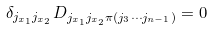Convert formula to latex. <formula><loc_0><loc_0><loc_500><loc_500>\delta _ { j _ { x _ { 1 } } j _ { x _ { 2 } } } D _ { j _ { x _ { 1 } } j _ { x _ { 2 } } \pi ( j _ { 3 } \cdots j _ { n - 1 } ) } = 0</formula> 